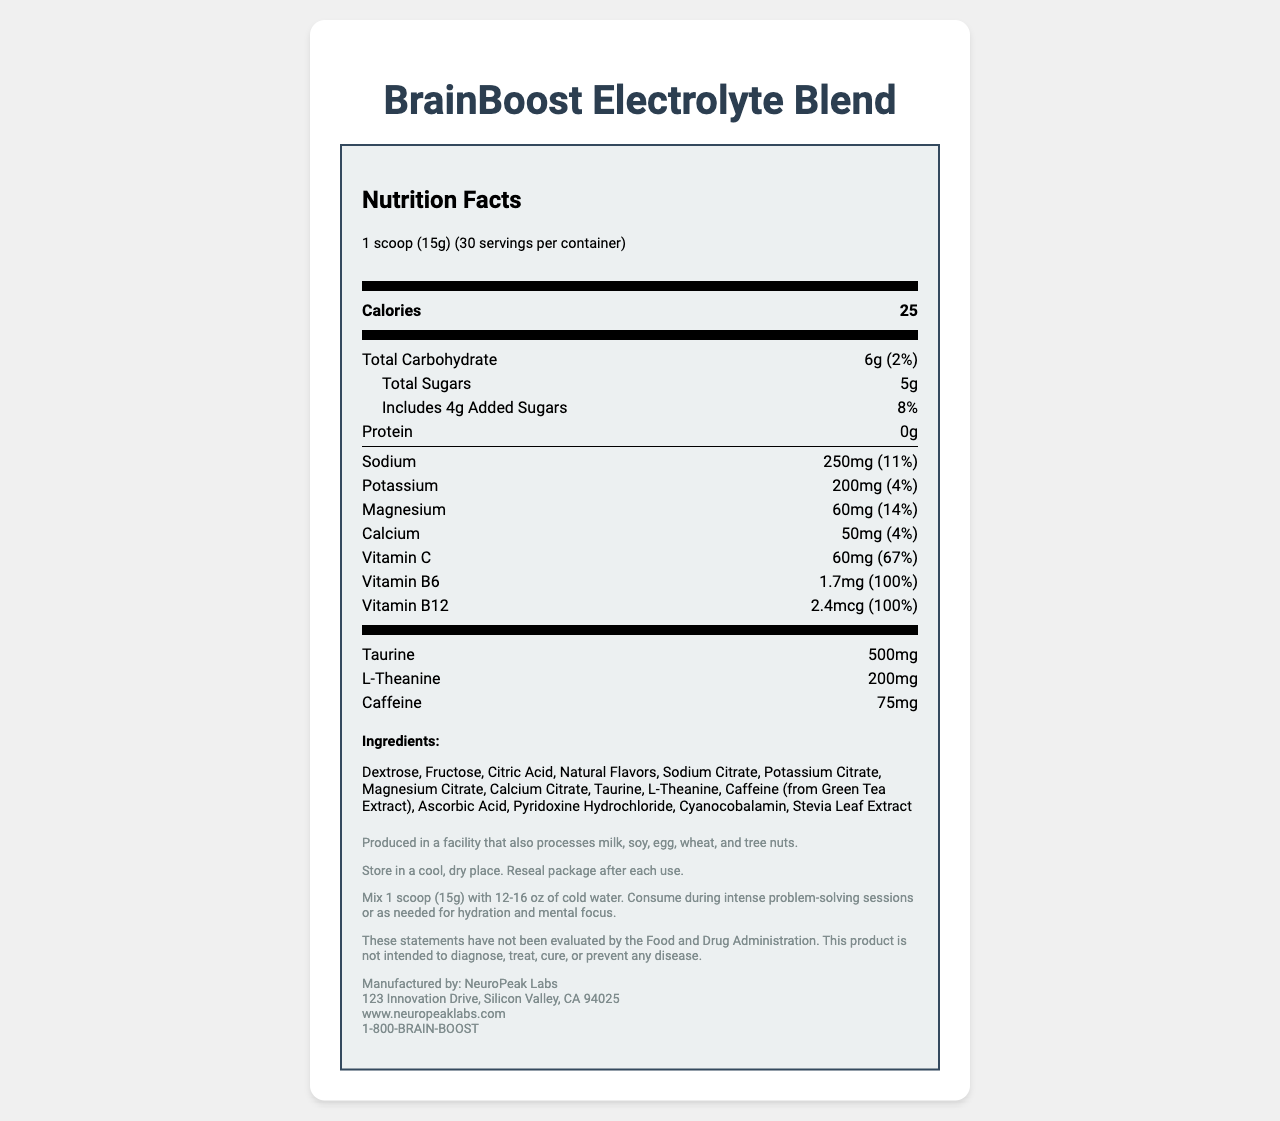what is the serving size of BrainBoost Electrolyte Blend? The serving size is clearly listed as "1 scoop (15g)" in the document.
Answer: 1 scoop (15g) how many calories are in one serving of the BrainBoost Electrolyte Blend? The document lists "Calories" as 25 per serving.
Answer: 25 calories how many servings are in one container of the BrainBoost Electrolyte Blend? The document states there are 30 servings per container.
Answer: 30 servings what is the total carbohydrate content in one serving? The total carbohydrate content per serving is listed as 6g.
Answer: 6g how much vitamin B12 is in one serving? The amount of vitamin B12 is stated as 2.4 mcg per serving.
Answer: 2.4 mcg how much sodium does one serving of BrainBoost Electrolyte Blend contain? A. 250mg B. 200mg C. 150mg D. 50mg Sodium content per serving is clearly listed as 250mg.
Answer: A. 250mg how much magnesium is present in a serving, in terms of percent daily value? 1. 4% 2. 14% 3. 11% 4. 67% The document specifies that one serving contains 60mg of magnesium, which is 14% of the daily value.
Answer: 2. 14% Does the product contain any protein? The document lists the protein content as 0g, indicating no protein in the product.
Answer: No Is this product intended to diagnose, treat, cure, or prevent any disease? The disclaimer clearly states that the product is not intended to diagnose, treat, cure, or prevent any disease.
Answer: No summarize the main idea of the document. The document presents a comprehensive breakdown of the product’s nutritional content, usage instructions, and other relevant information, aimed at potential consumers.
Answer: The document provides detailed Nutrition Facts for BrainBoost Electrolyte Blend, including ingredient list, allergen information, storage instructions, directions for use, and manufacturer details. what are the top ingredients listed for BrainBoost Electrolyte Blend? The ingredient list starts with Dextrose, Fructose, and Citric Acid, indicating these are some of the primary ingredients.
Answer: Dextrose, Fructose, Citric Acid what is the company’s contact phone number? The contact phone number as listed in the manufacturer's information is 1-800-BRAIN-BOOST.
Answer: 1-800-BRAIN-BOOST what is the sodium content in terms of percent daily value? The document states that 250mg of sodium per serving is equivalent to 11% of the daily value.
Answer: 11% how many grams of added sugars are included in one serving of this product? The added sugars amount to 4g per serving, as specified in the document.
Answer: 4g do we know the product price from this document? The document does not provide any information about the product's price.
Answer: Not enough information 